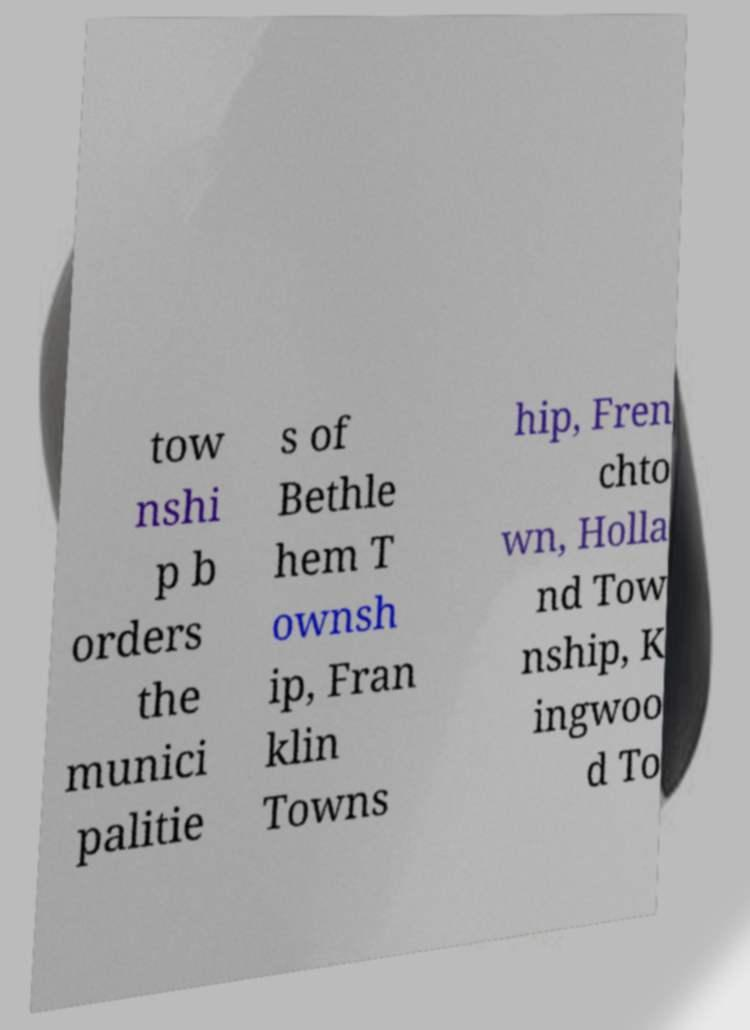Can you accurately transcribe the text from the provided image for me? tow nshi p b orders the munici palitie s of Bethle hem T ownsh ip, Fran klin Towns hip, Fren chto wn, Holla nd Tow nship, K ingwoo d To 